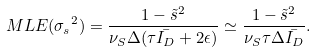<formula> <loc_0><loc_0><loc_500><loc_500>M L E ( { \sigma _ { s } } ^ { 2 } ) = \frac { 1 - \tilde { s } ^ { 2 } } { \nu _ { S } \Delta ( \tau \bar { I _ { D } } + 2 \epsilon ) } \simeq \frac { 1 - \tilde { s } ^ { 2 } } { \nu _ { S } \tau \Delta \bar { I _ { D } } } .</formula> 